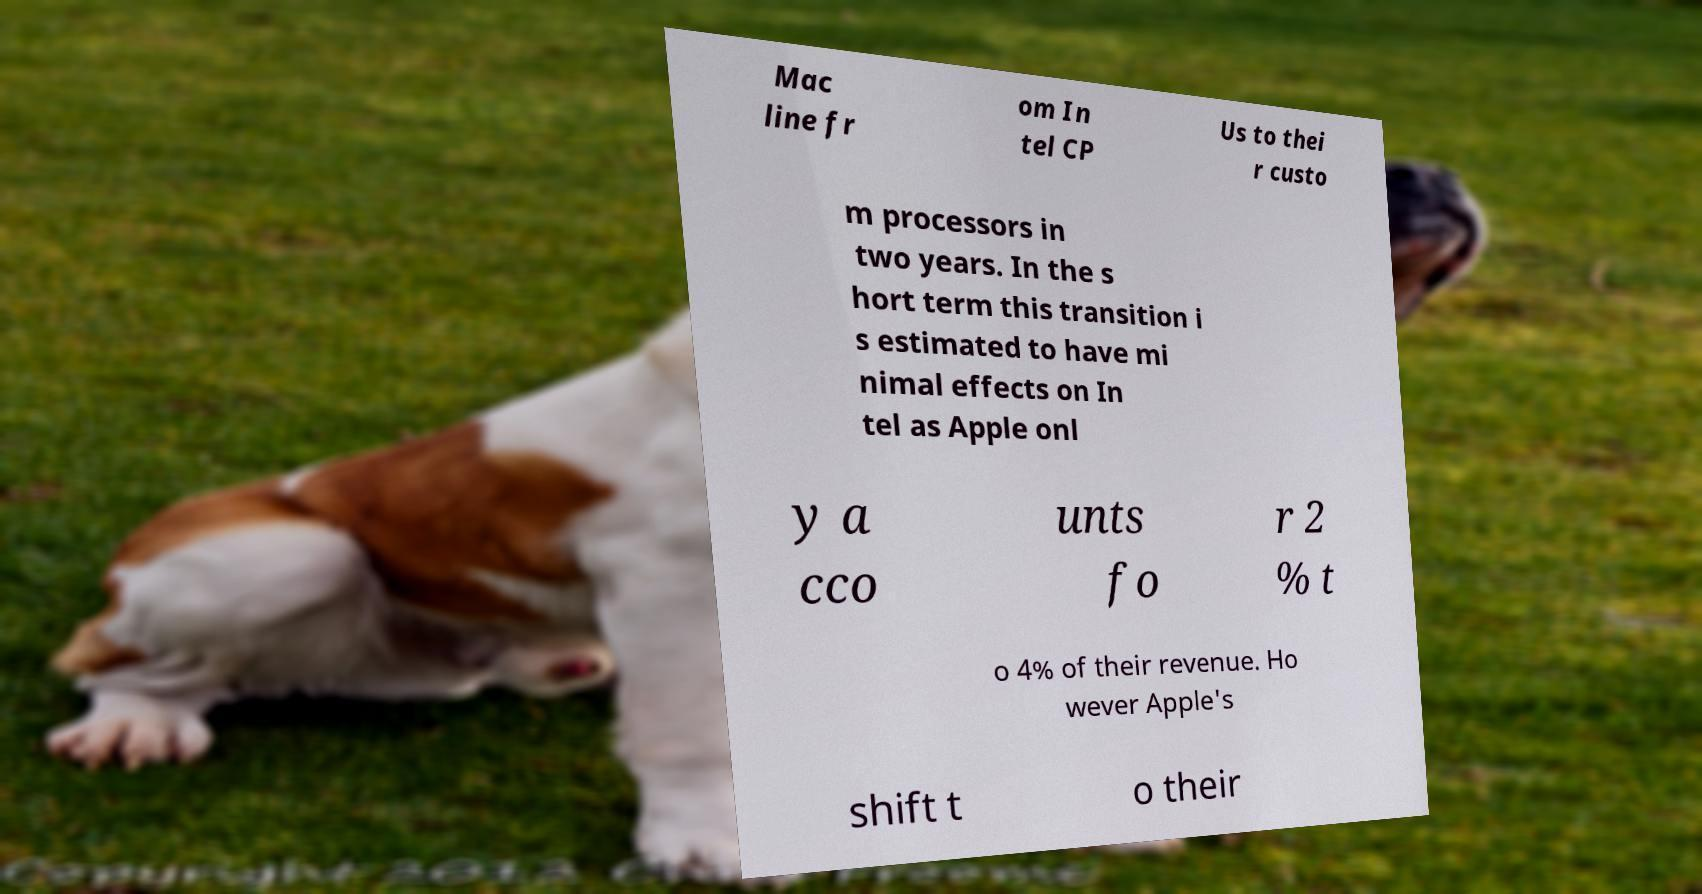Could you assist in decoding the text presented in this image and type it out clearly? Mac line fr om In tel CP Us to thei r custo m processors in two years. In the s hort term this transition i s estimated to have mi nimal effects on In tel as Apple onl y a cco unts fo r 2 % t o 4% of their revenue. Ho wever Apple's shift t o their 